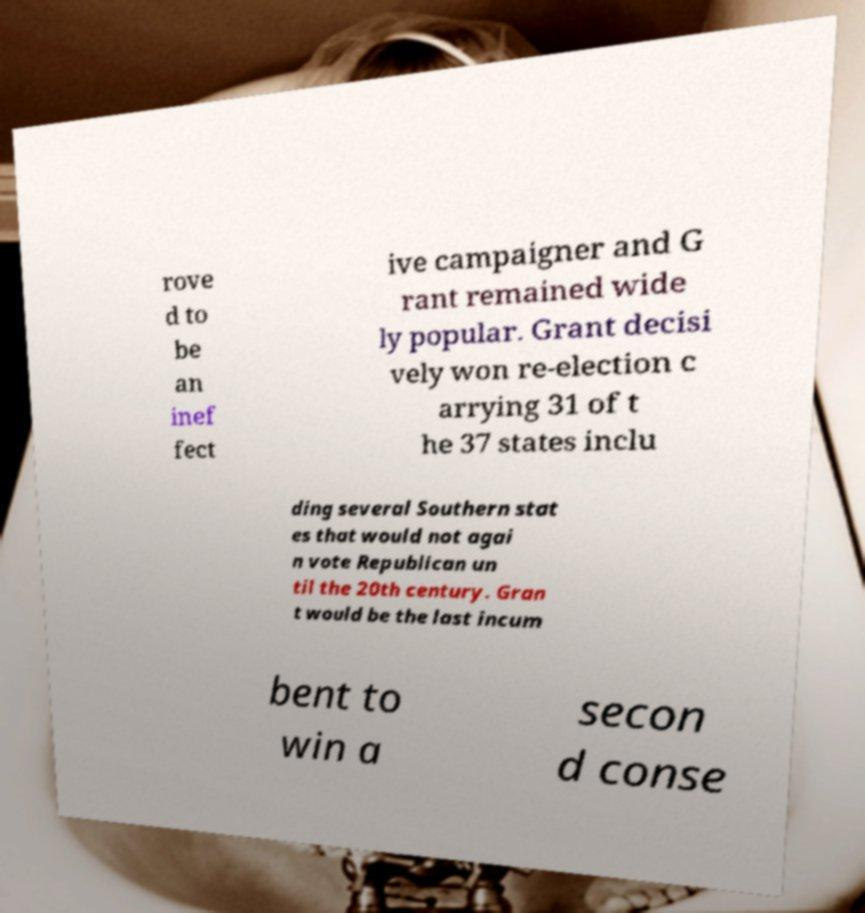Please read and relay the text visible in this image. What does it say? rove d to be an inef fect ive campaigner and G rant remained wide ly popular. Grant decisi vely won re-election c arrying 31 of t he 37 states inclu ding several Southern stat es that would not agai n vote Republican un til the 20th century. Gran t would be the last incum bent to win a secon d conse 